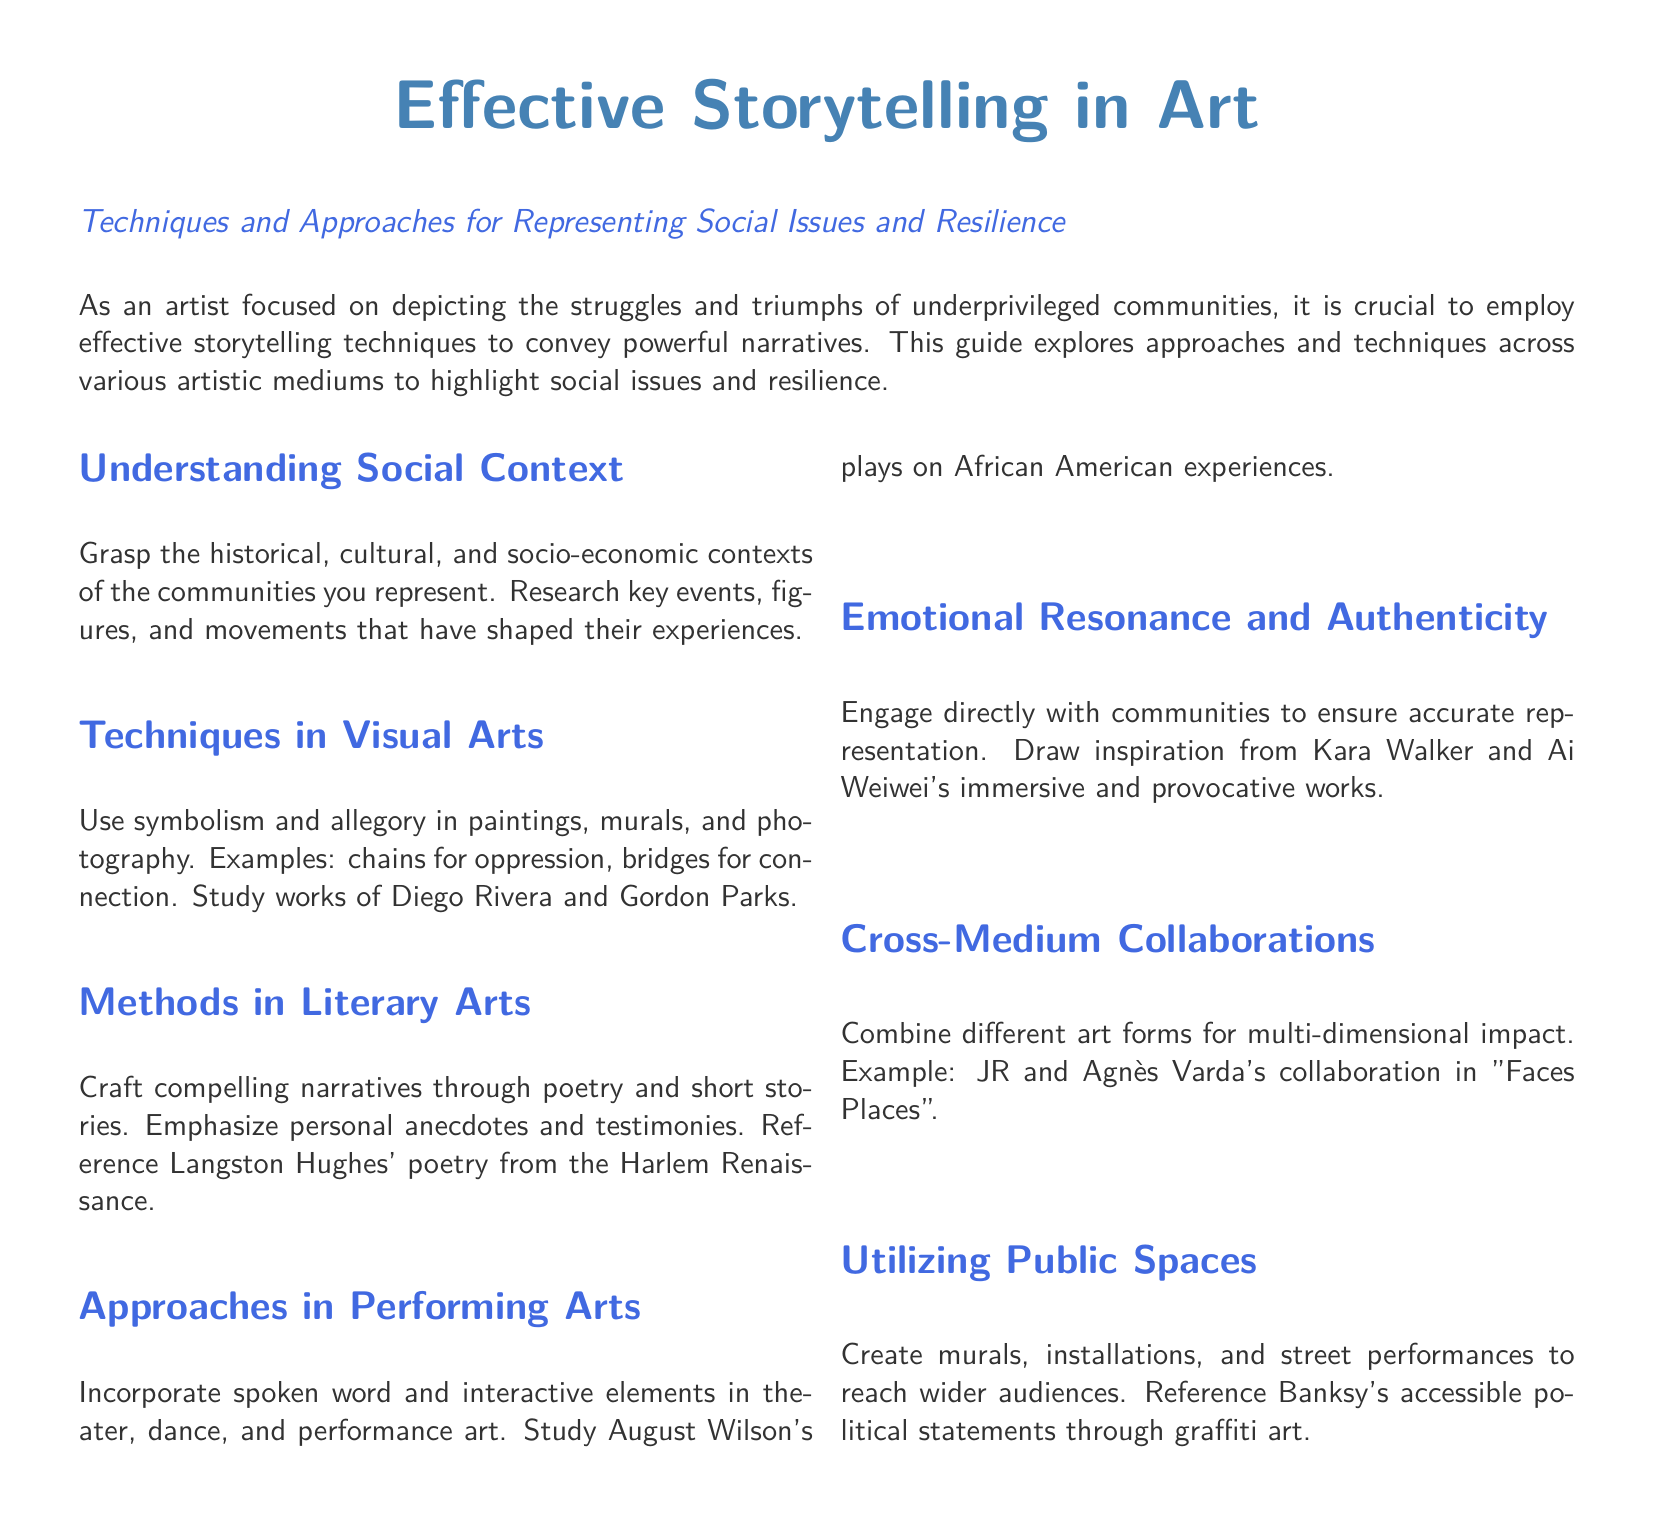What is the title of the guide? The title of the guide is prominently displayed at the beginning of the document.
Answer: Effective Storytelling in Art What is the primary focus of the guide? The primary focus of the guide is highlighted in the introduction section.
Answer: Representing social issues and resilience Who is referenced for techniques in visual arts? The guide mentions specific artists to reference for techniques in visual arts.
Answer: Diego Rivera and Gordon Parks What type of narrative is emphasized in the literary arts section? The guide specifies the type of narrative to focus on in the literary arts section.
Answer: Compelling narratives through poetry and short stories Which artist's works are referenced for emotional resonance and authenticity? The guide includes references to specific artists for inspiration in emotional resonance.
Answer: Kara Walker and Ai Weiwei What type of art does Banksy use for political statements? The guide mentions the form of art used by Banksy to make political statements.
Answer: Graffiti art What artistic collaboration is highlighted as an example of cross-medium impact? The guide provides a specific example of an artistic collaboration.
Answer: JR and Agnès Varda's collaboration in "Faces Places" What is a suggested method in performing arts? The guide provides recommendations for methods to use in performing arts.
Answer: Incorporate spoken word and interactive elements 